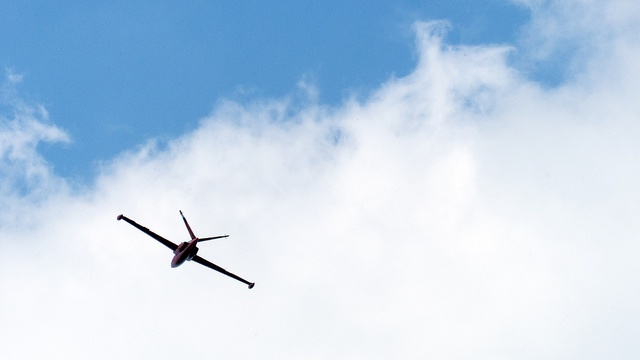Describe the objects in this image and their specific colors. I can see a airplane in lightblue, black, white, and purple tones in this image. 